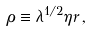<formula> <loc_0><loc_0><loc_500><loc_500>\rho \equiv \lambda ^ { 1 / 2 } \eta r \, ,</formula> 